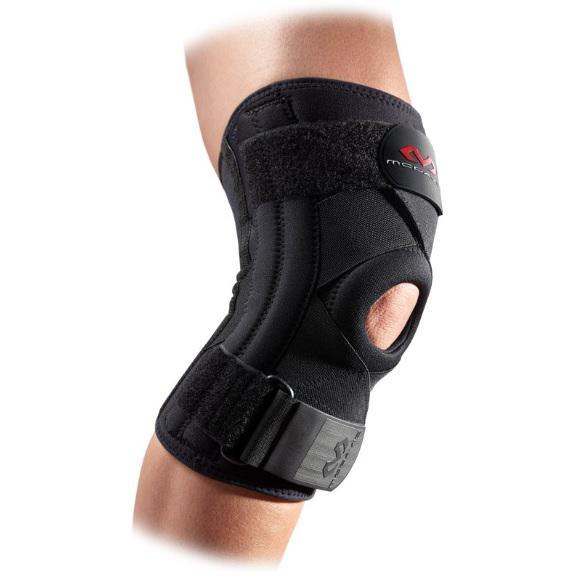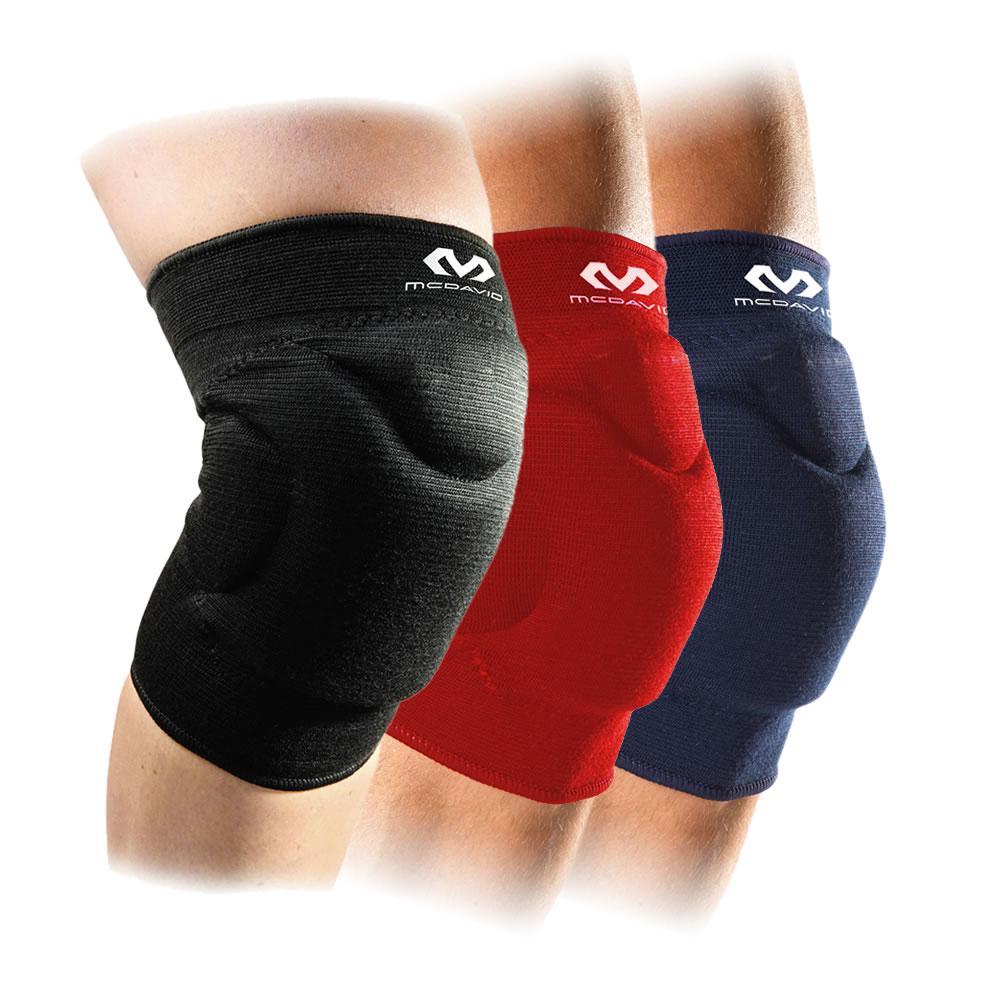The first image is the image on the left, the second image is the image on the right. Examine the images to the left and right. Is the description "one of the images is one a black background" accurate? Answer yes or no. No. The first image is the image on the left, the second image is the image on the right. Evaluate the accuracy of this statement regarding the images: "Exactly two knee braces are positioned on legs to show their proper use.". Is it true? Answer yes or no. No. 